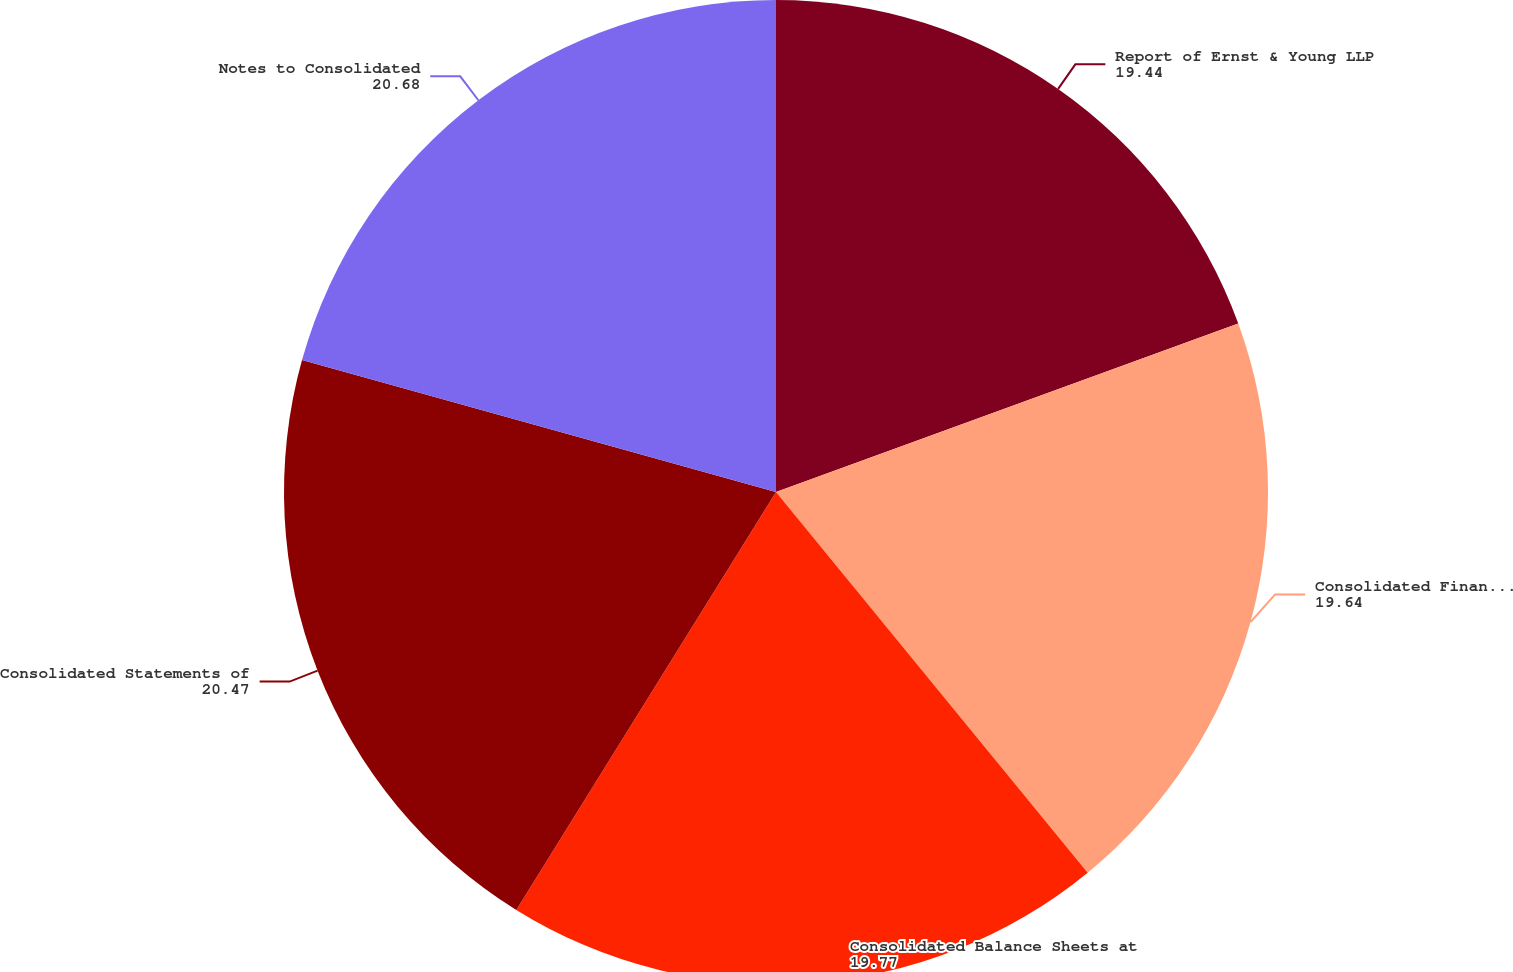<chart> <loc_0><loc_0><loc_500><loc_500><pie_chart><fcel>Report of Ernst & Young LLP<fcel>Consolidated Financial<fcel>Consolidated Balance Sheets at<fcel>Consolidated Statements of<fcel>Notes to Consolidated<nl><fcel>19.44%<fcel>19.64%<fcel>19.77%<fcel>20.47%<fcel>20.68%<nl></chart> 